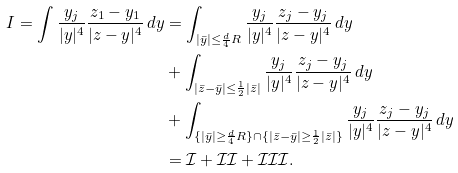<formula> <loc_0><loc_0><loc_500><loc_500>I = \int \frac { y _ { j } } { | y | ^ { 4 } } \frac { z _ { 1 } - y _ { 1 } } { | z - y | ^ { 4 } } \, d y & = \int _ { | \bar { y } | \leq \frac { d } { 4 } R } \frac { y _ { j } } { | y | ^ { 4 } } \frac { z _ { j } - y _ { j } } { | z - y | ^ { 4 } } \, d y \\ & + \int _ { | \bar { z } - \bar { y } | \leq \frac { 1 } { 2 } | \bar { z } | } \frac { y _ { j } } { | y | ^ { 4 } } \frac { z _ { j } - y _ { j } } { | z - y | ^ { 4 } } \, d y \\ & + \int _ { \{ | \bar { y } | \geq \frac { d } { 4 } R \} \cap \{ | \bar { z } - \bar { y } | \geq \frac { 1 } { 2 } | \bar { z } | \} } \frac { y _ { j } } { | y | ^ { 4 } } \frac { z _ { j } - y _ { j } } { | z - y | ^ { 4 } } \, d y \\ & = \mathcal { I } + \mathcal { I I } + \mathcal { I I I } .</formula> 